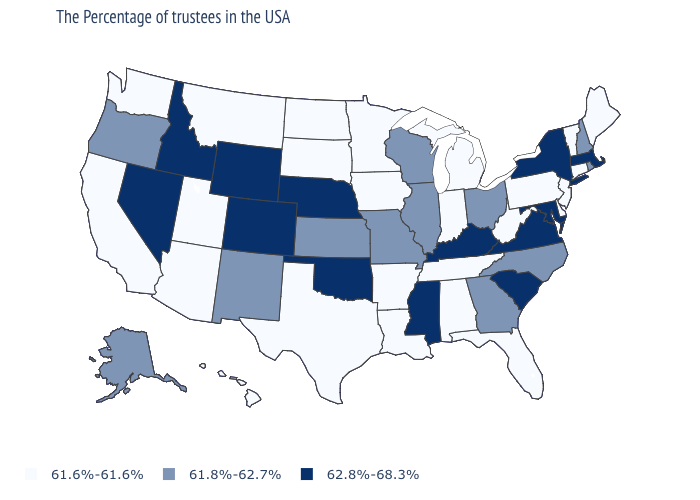Name the states that have a value in the range 61.8%-62.7%?
Quick response, please. Rhode Island, New Hampshire, North Carolina, Ohio, Georgia, Wisconsin, Illinois, Missouri, Kansas, New Mexico, Oregon, Alaska. What is the value of Oregon?
Concise answer only. 61.8%-62.7%. What is the value of Pennsylvania?
Short answer required. 61.6%-61.6%. Name the states that have a value in the range 61.6%-61.6%?
Quick response, please. Maine, Vermont, Connecticut, New Jersey, Delaware, Pennsylvania, West Virginia, Florida, Michigan, Indiana, Alabama, Tennessee, Louisiana, Arkansas, Minnesota, Iowa, Texas, South Dakota, North Dakota, Utah, Montana, Arizona, California, Washington, Hawaii. Name the states that have a value in the range 61.6%-61.6%?
Concise answer only. Maine, Vermont, Connecticut, New Jersey, Delaware, Pennsylvania, West Virginia, Florida, Michigan, Indiana, Alabama, Tennessee, Louisiana, Arkansas, Minnesota, Iowa, Texas, South Dakota, North Dakota, Utah, Montana, Arizona, California, Washington, Hawaii. What is the highest value in the USA?
Give a very brief answer. 62.8%-68.3%. What is the lowest value in states that border Indiana?
Be succinct. 61.6%-61.6%. Among the states that border Tennessee , does Virginia have the highest value?
Answer briefly. Yes. Which states have the lowest value in the USA?
Concise answer only. Maine, Vermont, Connecticut, New Jersey, Delaware, Pennsylvania, West Virginia, Florida, Michigan, Indiana, Alabama, Tennessee, Louisiana, Arkansas, Minnesota, Iowa, Texas, South Dakota, North Dakota, Utah, Montana, Arizona, California, Washington, Hawaii. Name the states that have a value in the range 61.6%-61.6%?
Short answer required. Maine, Vermont, Connecticut, New Jersey, Delaware, Pennsylvania, West Virginia, Florida, Michigan, Indiana, Alabama, Tennessee, Louisiana, Arkansas, Minnesota, Iowa, Texas, South Dakota, North Dakota, Utah, Montana, Arizona, California, Washington, Hawaii. Does Arizona have the lowest value in the West?
Answer briefly. Yes. Which states hav the highest value in the West?
Give a very brief answer. Wyoming, Colorado, Idaho, Nevada. What is the value of Utah?
Concise answer only. 61.6%-61.6%. Does New Hampshire have the lowest value in the USA?
Be succinct. No. Name the states that have a value in the range 61.8%-62.7%?
Concise answer only. Rhode Island, New Hampshire, North Carolina, Ohio, Georgia, Wisconsin, Illinois, Missouri, Kansas, New Mexico, Oregon, Alaska. 